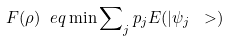Convert formula to latex. <formula><loc_0><loc_0><loc_500><loc_500>F ( \rho ) \ e q \min \sum \nolimits _ { j } p _ { j } E ( | \psi _ { j } \ > )</formula> 